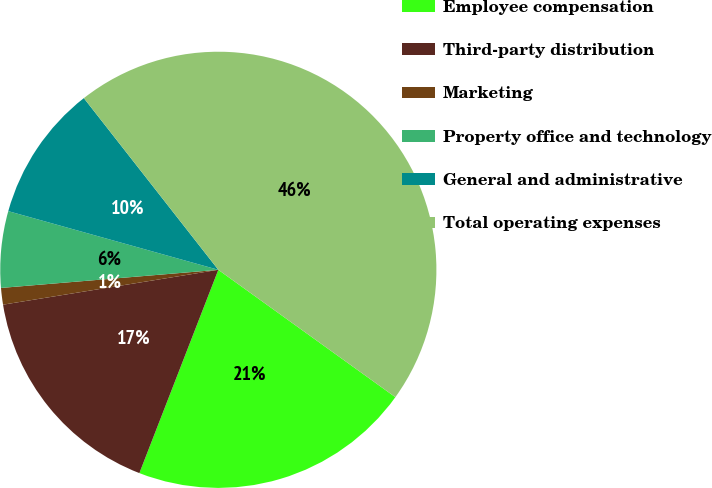<chart> <loc_0><loc_0><loc_500><loc_500><pie_chart><fcel>Employee compensation<fcel>Third-party distribution<fcel>Marketing<fcel>Property office and technology<fcel>General and administrative<fcel>Total operating expenses<nl><fcel>20.97%<fcel>16.55%<fcel>1.23%<fcel>5.66%<fcel>10.09%<fcel>45.5%<nl></chart> 